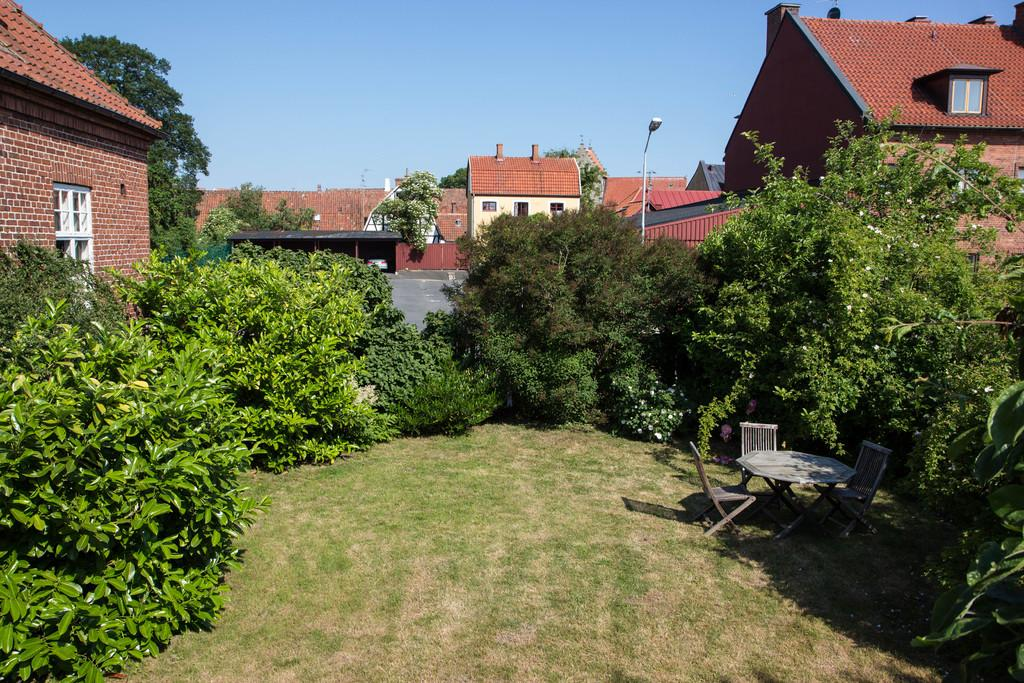What type of vegetation can be seen in the image? There are trees and grass in the image. What type of structures are visible in the image? There are buildings in the image. What furniture is located on the right side of the image? There are chairs and a table on the right side of the image. What objects can be seen in the background of the image? There is a pole and a light in the background of the image. What type of pipe is visible in the image? There is no pipe present in the image. What type of collar can be seen on the trees in the image? There are no collars on the trees in the image; they are natural trees. 